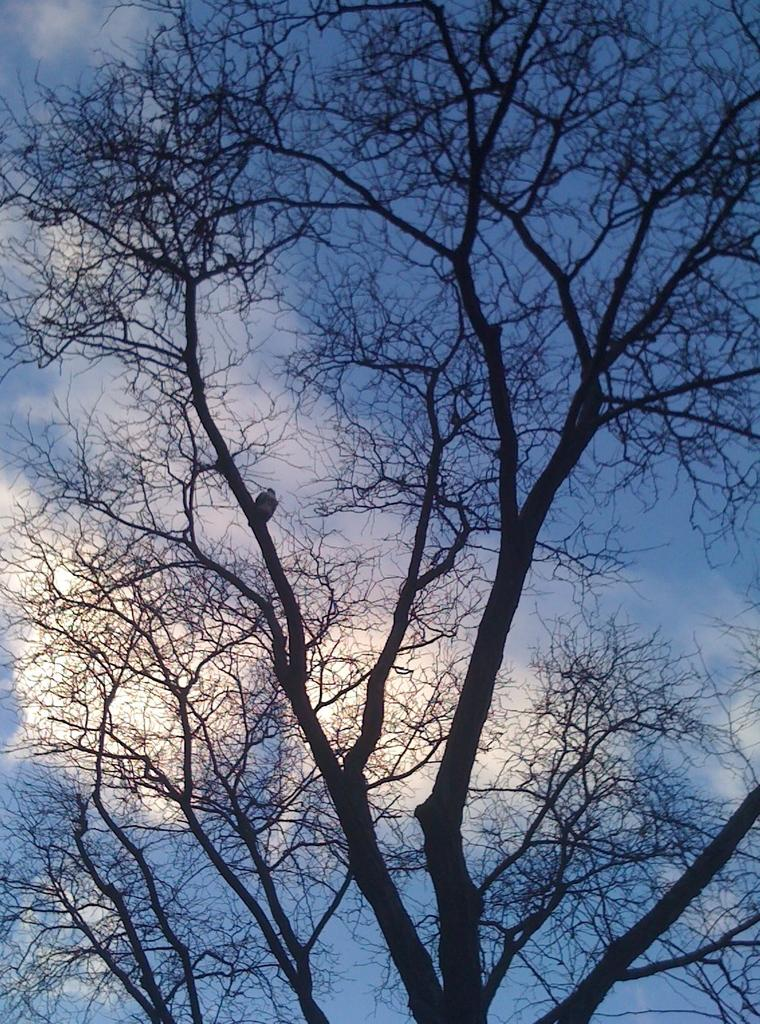What is the main object in the image? There is a tree in the image. Are there any animals present in the image? Yes, there is a bird on a branch of the tree. What can be seen in the background of the image? The sky is visible in the image. How would you describe the weather based on the sky? The sky appears to be cloudy. Where is the doctor in the image? There is no doctor present in the image. How many snakes are slithering around the tree in the image? There are no snakes present in the image. 